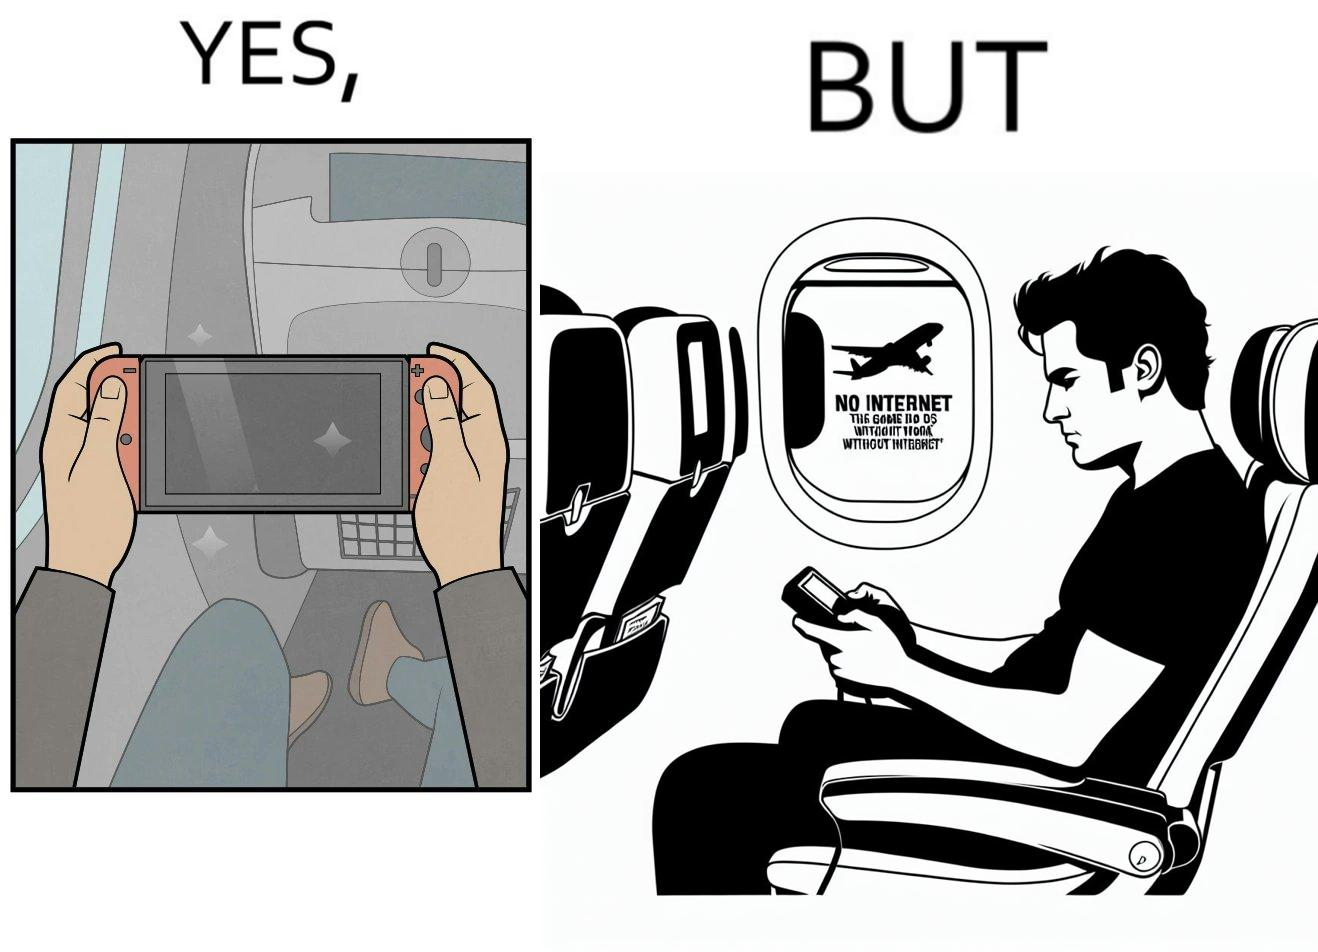Explain why this image is satirical. The image is ironic, as the person is holding the game console to play a game during the flight. However, the person is unable to play the game, as the game requires internet (as is the case with many modern games), and internet is unavailable in many lights. 